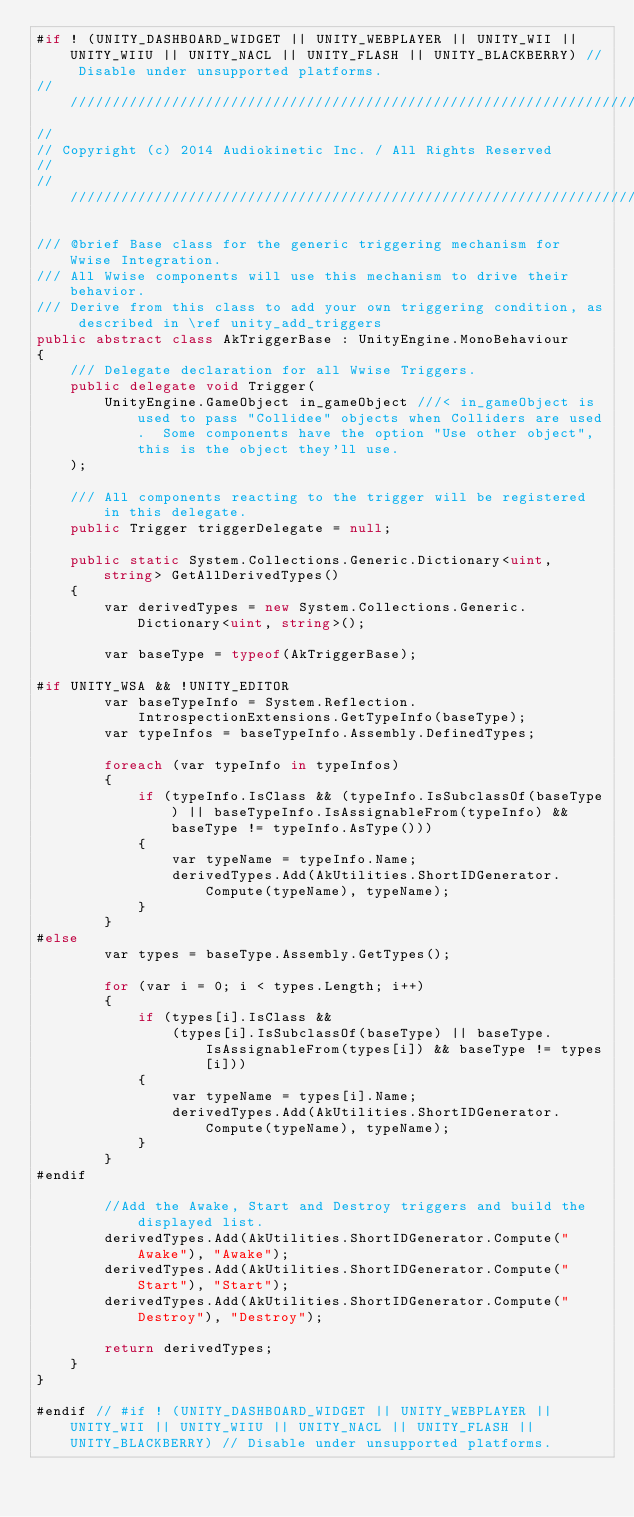<code> <loc_0><loc_0><loc_500><loc_500><_C#_>#if ! (UNITY_DASHBOARD_WIDGET || UNITY_WEBPLAYER || UNITY_WII || UNITY_WIIU || UNITY_NACL || UNITY_FLASH || UNITY_BLACKBERRY) // Disable under unsupported platforms.
//////////////////////////////////////////////////////////////////////
//
// Copyright (c) 2014 Audiokinetic Inc. / All Rights Reserved
//
//////////////////////////////////////////////////////////////////////

/// @brief Base class for the generic triggering mechanism for Wwise Integration.
/// All Wwise components will use this mechanism to drive their behavior.
/// Derive from this class to add your own triggering condition, as described in \ref unity_add_triggers
public abstract class AkTriggerBase : UnityEngine.MonoBehaviour
{
	/// Delegate declaration for all Wwise Triggers.
	public delegate void Trigger(
		UnityEngine.GameObject in_gameObject ///< in_gameObject is used to pass "Collidee" objects when Colliders are used.  Some components have the option "Use other object", this is the object they'll use.
	);

	/// All components reacting to the trigger will be registered in this delegate.
	public Trigger triggerDelegate = null;

	public static System.Collections.Generic.Dictionary<uint, string> GetAllDerivedTypes()
	{
		var derivedTypes = new System.Collections.Generic.Dictionary<uint, string>();

		var baseType = typeof(AkTriggerBase);

#if UNITY_WSA && !UNITY_EDITOR
		var baseTypeInfo = System.Reflection.IntrospectionExtensions.GetTypeInfo(baseType);
		var typeInfos = baseTypeInfo.Assembly.DefinedTypes;

		foreach (var typeInfo in typeInfos)
		{
			if (typeInfo.IsClass && (typeInfo.IsSubclassOf(baseType) || baseTypeInfo.IsAssignableFrom(typeInfo) && baseType != typeInfo.AsType()))
			{
				var typeName = typeInfo.Name;
				derivedTypes.Add(AkUtilities.ShortIDGenerator.Compute(typeName), typeName);
			}
		}
#else
		var types = baseType.Assembly.GetTypes();

		for (var i = 0; i < types.Length; i++)
		{
			if (types[i].IsClass &&
			    (types[i].IsSubclassOf(baseType) || baseType.IsAssignableFrom(types[i]) && baseType != types[i]))
			{
				var typeName = types[i].Name;
				derivedTypes.Add(AkUtilities.ShortIDGenerator.Compute(typeName), typeName);
			}
		}
#endif

		//Add the Awake, Start and Destroy triggers and build the displayed list.
		derivedTypes.Add(AkUtilities.ShortIDGenerator.Compute("Awake"), "Awake");
		derivedTypes.Add(AkUtilities.ShortIDGenerator.Compute("Start"), "Start");
		derivedTypes.Add(AkUtilities.ShortIDGenerator.Compute("Destroy"), "Destroy");

		return derivedTypes;
	}
}

#endif // #if ! (UNITY_DASHBOARD_WIDGET || UNITY_WEBPLAYER || UNITY_WII || UNITY_WIIU || UNITY_NACL || UNITY_FLASH || UNITY_BLACKBERRY) // Disable under unsupported platforms.</code> 